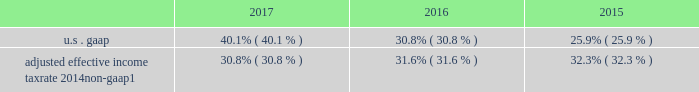Management 2019s discussion and analysis supplemental financial information and disclosures income tax matters effective tax rate from continuing operations .
Adjusted effective income tax rate 2014 non-gaap1 30.8% ( 30.8 % ) 31.6% ( 31.6 % ) 32.3% ( 32.3 % ) 1 .
Beginning in 2017 , income tax consequences associated with employee share-based awards are recognized in provision for income taxes in the income statements but are excluded from the intermittent net discrete tax provisions ( benefits ) adjustment as we anticipate conversion activity each year .
See note 2 to the financial statements on the adoption of the accounting update improvements to employee share-based payment accounting .
For 2015 , adjusted effective income tax rate also excludes dva .
For further information on non-gaap measures , see 201cselected non-gaap financial information 201d herein .
The effective tax rate from continuing operations for 2017 included an intermittent net discrete tax provision of $ 968 million , primarily related to the impact of the tax act , partially offset by net discrete tax benefits primarily associ- ated with the remeasurement of reserves and related interest due to new information regarding the status of multi-year irs tax examinations .
The tax act , enacted on december 22 , 2017 , significantly revised u.s .
Corporate income tax law by , among other things , reducing the corporate income tax rate to 21% ( 21 % ) , and implementing a modified territorial tax system that includes a one-time transition tax on deemed repatriated earnings of non-u.s .
Subsidiaries ; imposes a minimum tax on global intangible low-taxed income ( 201cgilti 201d ) and an alternative base erosion and anti-abuse tax ( 201cbeat 201d ) on u.s .
Corpora- tions that make deductible payments to non-u.s .
Related persons in excess of specified amounts ; and broadens the tax base by partially or wholly eliminating tax deductions for certain historically deductible expenses ( e.g. , fdic premiums and executive compensation ) .
We recorded an approximate $ 1.2 billion net discrete tax provision as a result of the enactment of the tax act , primarily from the remeasurement of certain deferred tax assets using the lower enacted corporate tax rate .
This provi- sion incorporates the best available information as of the enactment date as well as assumptions made based upon our current interpretation of the tax act .
Our estimates may change as we receive additional clarification and implementa- tion guidance from the u.s .
Treasury department and as the interpretation of the tax act evolves over time .
The ultimate impact of the income tax effects of the tax act will be deter- mined in connection with the preparation of our u.s .
Consoli- dated federal income tax return .
Taking into account our current assumptions , estimates and interpretations related to the tax act and other factors , we expect our effective tax rate from continuing operations for 2018 to be approximately 22% ( 22 % ) to 25% ( 25 % ) , depending on factors such as the geographic mix of earnings and employee share- based awards ( see 201cforward-looking statements 201d ) .
Subsequent to the release of the firm 2019s 2017 earnings on january 18 , 2018 , certain estimates related to the net discrete tax provision associated with the enactment of the tax act were revised , resulting in a $ 43 million increase in the provi- sion for income taxes and a reallocation of impacts among segments .
This decreased diluted eps and diluted eps from continuing operations by $ 0.03 and $ 0.02 in the fourth quarter and year ended december 31 , 2017 , respectively .
On a business segment basis , the change resulted in an $ 89 million increase in provision for income taxes for wealth management , a $ 45 million decrease for institutional securi- ties , and a $ 1 million decrease for investment management .
The effective tax rate from continuing operations for 2016 included intermittent net discrete tax benefits of $ 68 million , primarily related to the remeasurement of reserves and related interest due to new information regarding the status of multi- year irs tax examinations , partially offset by adjustments for other tax matters .
The effective tax rate from continuing operations for 2015 included intermittent net discrete tax benefits of $ 564 million , primarily associated with the repatriation of non-u.s .
Earn- ings at a cost lower than originally estimated due to an internal restructuring to simplify the legal entity organization in the u.k .
U.s .
Bank subsidiaries we provide loans to a variety of customers , from large corpo- rate and institutional clients to high net worth individuals , primarily through our u.s .
Bank subsidiaries , morgan stanley bank n.a .
( 201cmsbna 201d ) and morgan stanley private bank , national association ( 201cmspbna 201d ) ( collectively , 201cu.s .
Bank subsidiaries 201d ) .
The lending activities in the institutional securities business segment primarily include loans and lending commitments to corporate clients .
The lending activ- ities in the wealth management business segment primarily include securities-based lending that allows clients to borrow december 2017 form 10-k 52 .
What is the difference between u.s . gaap and adjusted effective income tax rate 2014non-gaap in 2015? 
Computations: (25.9 - 32.3)
Answer: -6.4. 